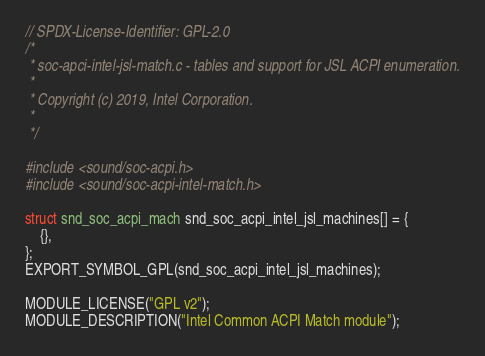<code> <loc_0><loc_0><loc_500><loc_500><_C_>// SPDX-License-Identifier: GPL-2.0
/*
 * soc-apci-intel-jsl-match.c - tables and support for JSL ACPI enumeration.
 *
 * Copyright (c) 2019, Intel Corporation.
 *
 */

#include <sound/soc-acpi.h>
#include <sound/soc-acpi-intel-match.h>

struct snd_soc_acpi_mach snd_soc_acpi_intel_jsl_machines[] = {
	{},
};
EXPORT_SYMBOL_GPL(snd_soc_acpi_intel_jsl_machines);

MODULE_LICENSE("GPL v2");
MODULE_DESCRIPTION("Intel Common ACPI Match module");
</code> 